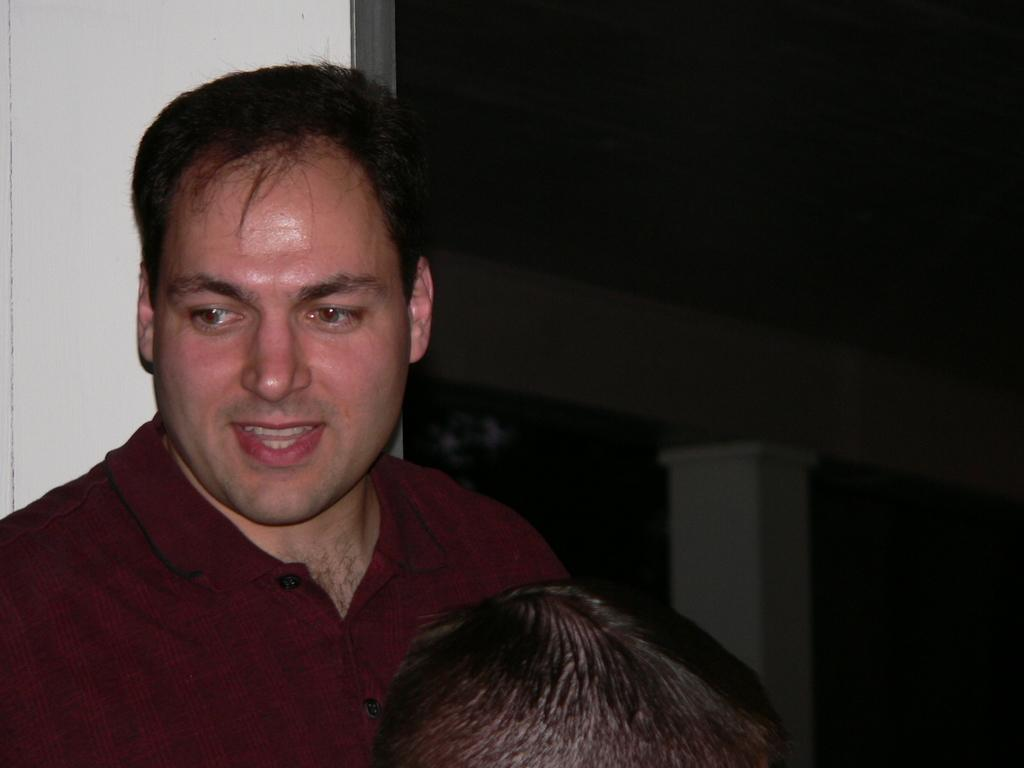What is the main subject of the image? There is a man in the image. What is the man wearing? The man is wearing a maroon color T-shirt. Can you describe the person in front of the man? There is another person in front of the man, but no specific details about their appearance are provided. Reasoning: Let' Let's think step by step in order to produce the conversation. We start by identifying the main subject of the image, which is the man. Then, we describe his clothing to provide more detail about his appearance. Finally, we mention the presence of another person in front of the man, but since no specific details are given, we cannot elaborate further. Absurd Question/Answer: What type of coil is being used by the man to hammer in the image? There is no coil or hammer present in the image; the man is simply standing and wearing a maroon color T-shirt. 